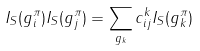Convert formula to latex. <formula><loc_0><loc_0><loc_500><loc_500>I _ { S } ( g _ { i } ^ { \pi } ) I _ { S } ( g _ { j } ^ { \pi } ) = \sum _ { g _ { k } } c _ { i j } ^ { k } I _ { S } ( g _ { k } ^ { \pi } )</formula> 